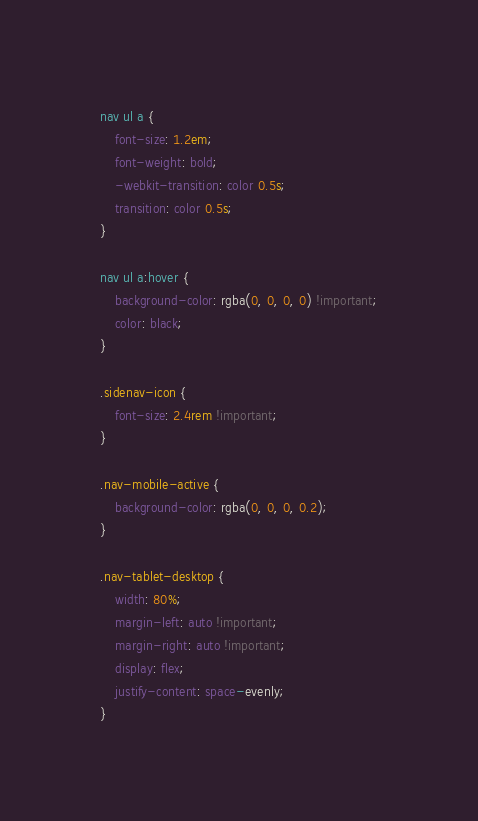Convert code to text. <code><loc_0><loc_0><loc_500><loc_500><_CSS_>nav ul a {
    font-size: 1.2em;
    font-weight: bold;
    -webkit-transition: color 0.5s;
    transition: color 0.5s;
}

nav ul a:hover {
    background-color: rgba(0, 0, 0, 0) !important;
    color: black;
}

.sidenav-icon {
    font-size: 2.4rem !important;
}

.nav-mobile-active {
    background-color: rgba(0, 0, 0, 0.2);
}

.nav-tablet-desktop {
    width: 80%;
    margin-left: auto !important;
    margin-right: auto !important;
    display: flex;
    justify-content: space-evenly;
}</code> 